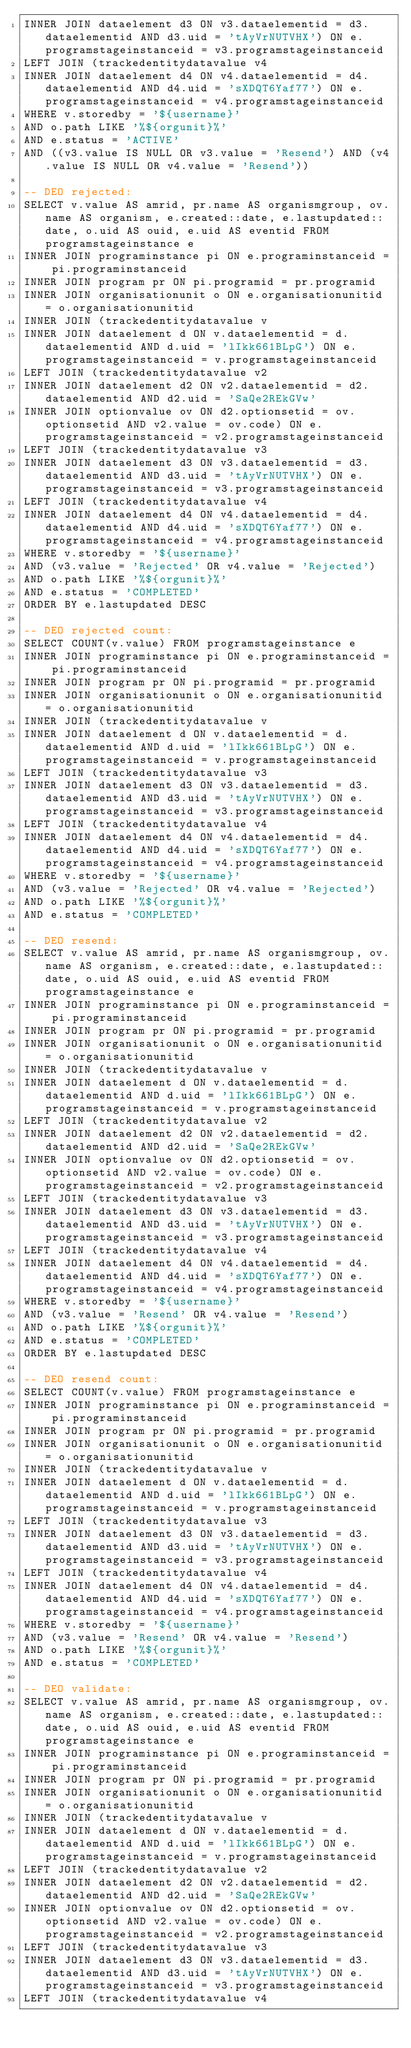Convert code to text. <code><loc_0><loc_0><loc_500><loc_500><_SQL_>INNER JOIN dataelement d3 ON v3.dataelementid = d3.dataelementid AND d3.uid = 'tAyVrNUTVHX') ON e.programstageinstanceid = v3.programstageinstanceid
LEFT JOIN (trackedentitydatavalue v4
INNER JOIN dataelement d4 ON v4.dataelementid = d4.dataelementid AND d4.uid = 'sXDQT6Yaf77') ON e.programstageinstanceid = v4.programstageinstanceid
WHERE v.storedby = '${username}'
AND o.path LIKE '%${orgunit}%'
AND e.status = 'ACTIVE'
AND ((v3.value IS NULL OR v3.value = 'Resend') AND (v4.value IS NULL OR v4.value = 'Resend'))

-- DEO rejected:
SELECT v.value AS amrid, pr.name AS organismgroup, ov.name AS organism, e.created::date, e.lastupdated::date, o.uid AS ouid, e.uid AS eventid FROM programstageinstance e
INNER JOIN programinstance pi ON e.programinstanceid = pi.programinstanceid
INNER JOIN program pr ON pi.programid = pr.programid
INNER JOIN organisationunit o ON e.organisationunitid = o.organisationunitid
INNER JOIN (trackedentitydatavalue v
INNER JOIN dataelement d ON v.dataelementid = d.dataelementid AND d.uid = 'lIkk661BLpG') ON e.programstageinstanceid = v.programstageinstanceid
LEFT JOIN (trackedentitydatavalue v2
INNER JOIN dataelement d2 ON v2.dataelementid = d2.dataelementid AND d2.uid = 'SaQe2REkGVw'
INNER JOIN optionvalue ov ON d2.optionsetid = ov.optionsetid AND v2.value = ov.code) ON e.programstageinstanceid = v2.programstageinstanceid
LEFT JOIN (trackedentitydatavalue v3
INNER JOIN dataelement d3 ON v3.dataelementid = d3.dataelementid AND d3.uid = 'tAyVrNUTVHX') ON e.programstageinstanceid = v3.programstageinstanceid
LEFT JOIN (trackedentitydatavalue v4
INNER JOIN dataelement d4 ON v4.dataelementid = d4.dataelementid AND d4.uid = 'sXDQT6Yaf77') ON e.programstageinstanceid = v4.programstageinstanceid
WHERE v.storedby = '${username}'
AND (v3.value = 'Rejected' OR v4.value = 'Rejected')
AND o.path LIKE '%${orgunit}%'
AND e.status = 'COMPLETED'
ORDER BY e.lastupdated DESC

-- DEO rejected count:
SELECT COUNT(v.value) FROM programstageinstance e
INNER JOIN programinstance pi ON e.programinstanceid = pi.programinstanceid
INNER JOIN program pr ON pi.programid = pr.programid
INNER JOIN organisationunit o ON e.organisationunitid = o.organisationunitid
INNER JOIN (trackedentitydatavalue v
INNER JOIN dataelement d ON v.dataelementid = d.dataelementid AND d.uid = 'lIkk661BLpG') ON e.programstageinstanceid = v.programstageinstanceid
LEFT JOIN (trackedentitydatavalue v3
INNER JOIN dataelement d3 ON v3.dataelementid = d3.dataelementid AND d3.uid = 'tAyVrNUTVHX') ON e.programstageinstanceid = v3.programstageinstanceid
LEFT JOIN (trackedentitydatavalue v4
INNER JOIN dataelement d4 ON v4.dataelementid = d4.dataelementid AND d4.uid = 'sXDQT6Yaf77') ON e.programstageinstanceid = v4.programstageinstanceid
WHERE v.storedby = '${username}'
AND (v3.value = 'Rejected' OR v4.value = 'Rejected')
AND o.path LIKE '%${orgunit}%'
AND e.status = 'COMPLETED'

-- DEO resend:
SELECT v.value AS amrid, pr.name AS organismgroup, ov.name AS organism, e.created::date, e.lastupdated::date, o.uid AS ouid, e.uid AS eventid FROM programstageinstance e
INNER JOIN programinstance pi ON e.programinstanceid = pi.programinstanceid
INNER JOIN program pr ON pi.programid = pr.programid
INNER JOIN organisationunit o ON e.organisationunitid = o.organisationunitid
INNER JOIN (trackedentitydatavalue v
INNER JOIN dataelement d ON v.dataelementid = d.dataelementid AND d.uid = 'lIkk661BLpG') ON e.programstageinstanceid = v.programstageinstanceid
LEFT JOIN (trackedentitydatavalue v2
INNER JOIN dataelement d2 ON v2.dataelementid = d2.dataelementid AND d2.uid = 'SaQe2REkGVw'
INNER JOIN optionvalue ov ON d2.optionsetid = ov.optionsetid AND v2.value = ov.code) ON e.programstageinstanceid = v2.programstageinstanceid
LEFT JOIN (trackedentitydatavalue v3
INNER JOIN dataelement d3 ON v3.dataelementid = d3.dataelementid AND d3.uid = 'tAyVrNUTVHX') ON e.programstageinstanceid = v3.programstageinstanceid
LEFT JOIN (trackedentitydatavalue v4
INNER JOIN dataelement d4 ON v4.dataelementid = d4.dataelementid AND d4.uid = 'sXDQT6Yaf77') ON e.programstageinstanceid = v4.programstageinstanceid
WHERE v.storedby = '${username}'
AND (v3.value = 'Resend' OR v4.value = 'Resend')
AND o.path LIKE '%${orgunit}%'
AND e.status = 'COMPLETED'
ORDER BY e.lastupdated DESC

-- DEO resend count:
SELECT COUNT(v.value) FROM programstageinstance e
INNER JOIN programinstance pi ON e.programinstanceid = pi.programinstanceid
INNER JOIN program pr ON pi.programid = pr.programid
INNER JOIN organisationunit o ON e.organisationunitid = o.organisationunitid
INNER JOIN (trackedentitydatavalue v
INNER JOIN dataelement d ON v.dataelementid = d.dataelementid AND d.uid = 'lIkk661BLpG') ON e.programstageinstanceid = v.programstageinstanceid
LEFT JOIN (trackedentitydatavalue v3
INNER JOIN dataelement d3 ON v3.dataelementid = d3.dataelementid AND d3.uid = 'tAyVrNUTVHX') ON e.programstageinstanceid = v3.programstageinstanceid
LEFT JOIN (trackedentitydatavalue v4
INNER JOIN dataelement d4 ON v4.dataelementid = d4.dataelementid AND d4.uid = 'sXDQT6Yaf77') ON e.programstageinstanceid = v4.programstageinstanceid
WHERE v.storedby = '${username}'
AND (v3.value = 'Resend' OR v4.value = 'Resend')
AND o.path LIKE '%${orgunit}%'
AND e.status = 'COMPLETED'

-- DEO validate:
SELECT v.value AS amrid, pr.name AS organismgroup, ov.name AS organism, e.created::date, e.lastupdated::date, o.uid AS ouid, e.uid AS eventid FROM programstageinstance e
INNER JOIN programinstance pi ON e.programinstanceid = pi.programinstanceid
INNER JOIN program pr ON pi.programid = pr.programid
INNER JOIN organisationunit o ON e.organisationunitid = o.organisationunitid
INNER JOIN (trackedentitydatavalue v
INNER JOIN dataelement d ON v.dataelementid = d.dataelementid AND d.uid = 'lIkk661BLpG') ON e.programstageinstanceid = v.programstageinstanceid
LEFT JOIN (trackedentitydatavalue v2
INNER JOIN dataelement d2 ON v2.dataelementid = d2.dataelementid AND d2.uid = 'SaQe2REkGVw'
INNER JOIN optionvalue ov ON d2.optionsetid = ov.optionsetid AND v2.value = ov.code) ON e.programstageinstanceid = v2.programstageinstanceid
LEFT JOIN (trackedentitydatavalue v3
INNER JOIN dataelement d3 ON v3.dataelementid = d3.dataelementid AND d3.uid = 'tAyVrNUTVHX') ON e.programstageinstanceid = v3.programstageinstanceid
LEFT JOIN (trackedentitydatavalue v4</code> 